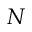Convert formula to latex. <formula><loc_0><loc_0><loc_500><loc_500>N</formula> 